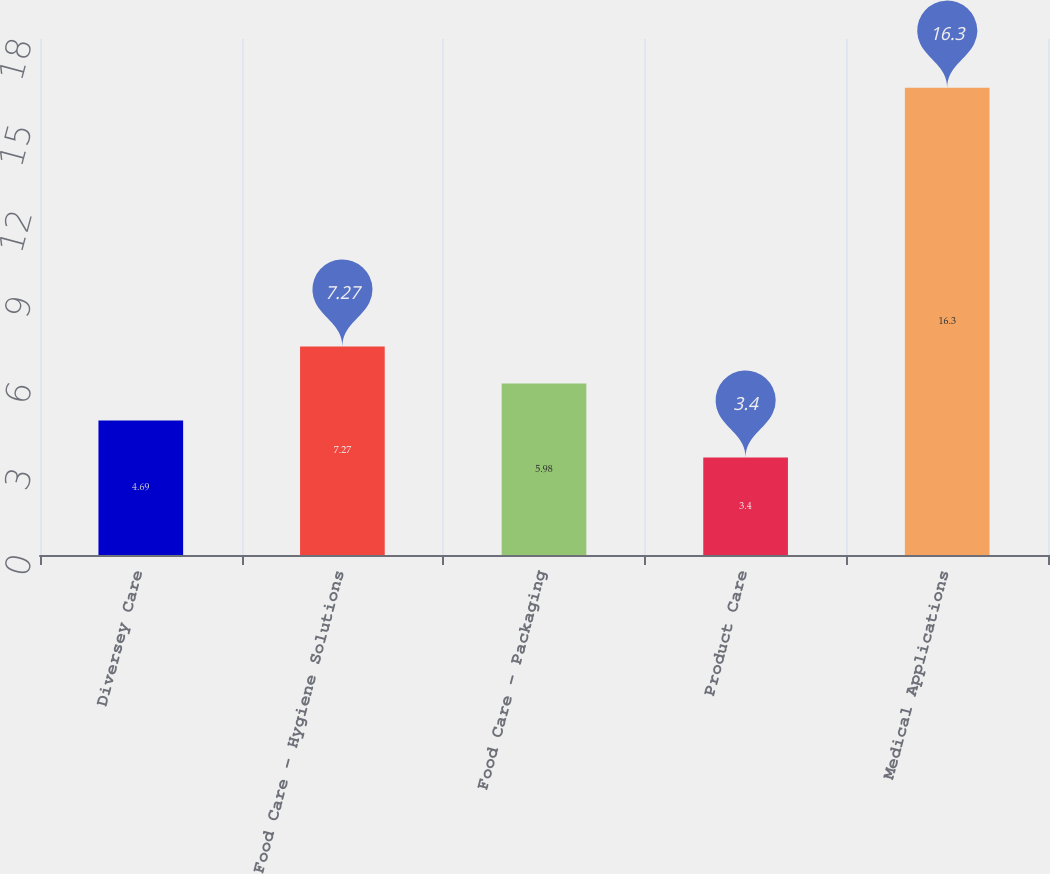<chart> <loc_0><loc_0><loc_500><loc_500><bar_chart><fcel>Diversey Care<fcel>Food Care - Hygiene Solutions<fcel>Food Care - Packaging<fcel>Product Care<fcel>Medical Applications<nl><fcel>4.69<fcel>7.27<fcel>5.98<fcel>3.4<fcel>16.3<nl></chart> 